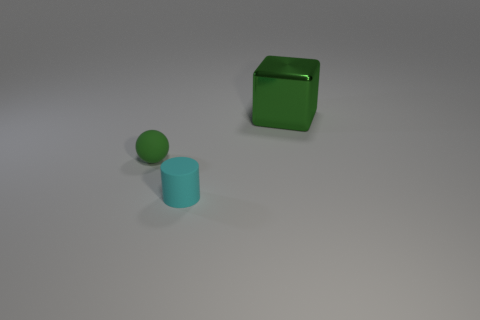Add 1 small brown metal cylinders. How many objects exist? 4 Subtract 1 balls. How many balls are left? 0 Subtract all balls. How many objects are left? 2 Subtract all cyan cubes. How many brown cylinders are left? 0 Subtract 1 green balls. How many objects are left? 2 Subtract all purple spheres. Subtract all blue cylinders. How many spheres are left? 1 Subtract all big green metallic objects. Subtract all cubes. How many objects are left? 1 Add 1 small cyan cylinders. How many small cyan cylinders are left? 2 Add 2 tiny brown shiny blocks. How many tiny brown shiny blocks exist? 2 